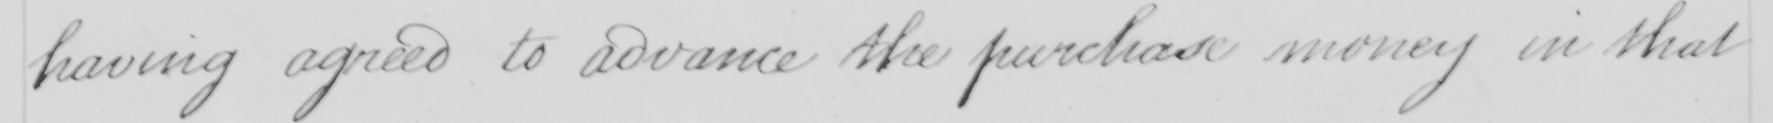What is written in this line of handwriting? having agreed to advance the purchase money in that 